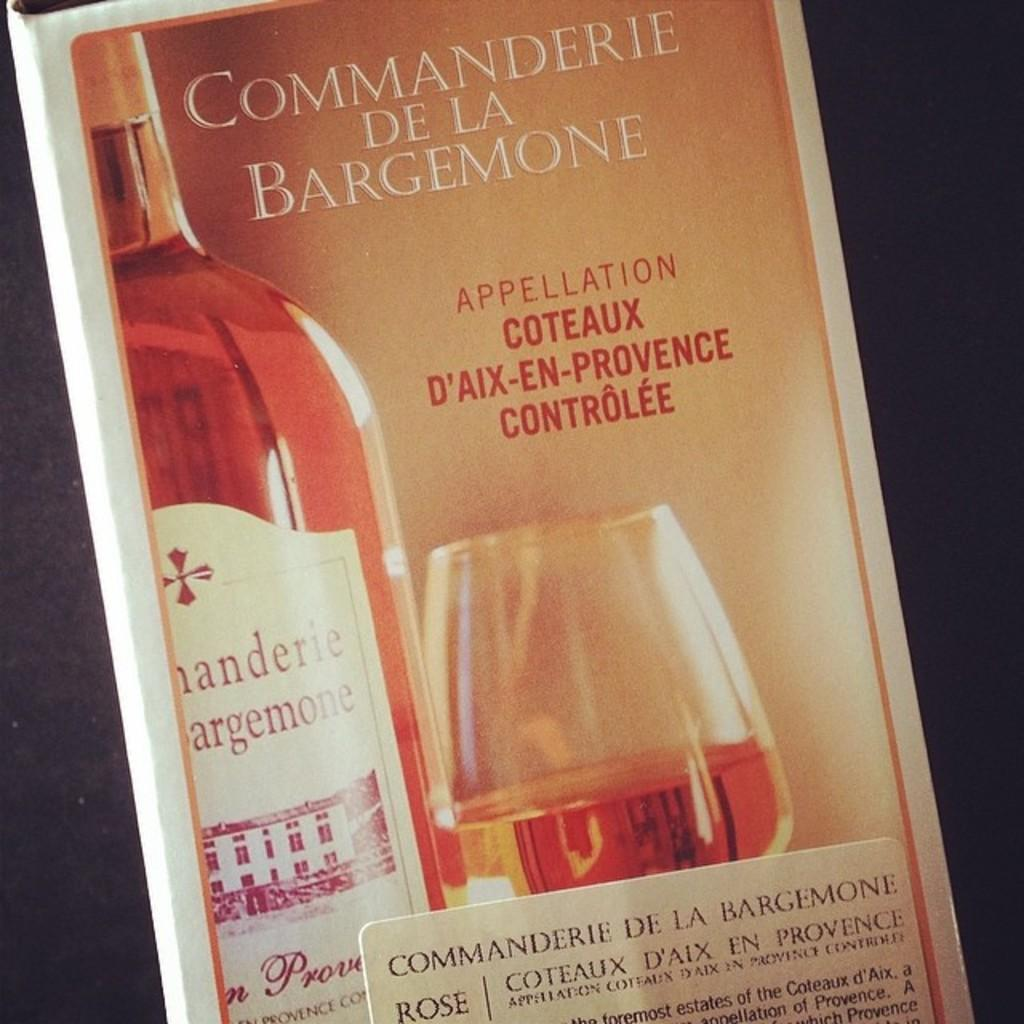<image>
Offer a succinct explanation of the picture presented. Box of alcohol that says "Commanderie De La Bargemone". 